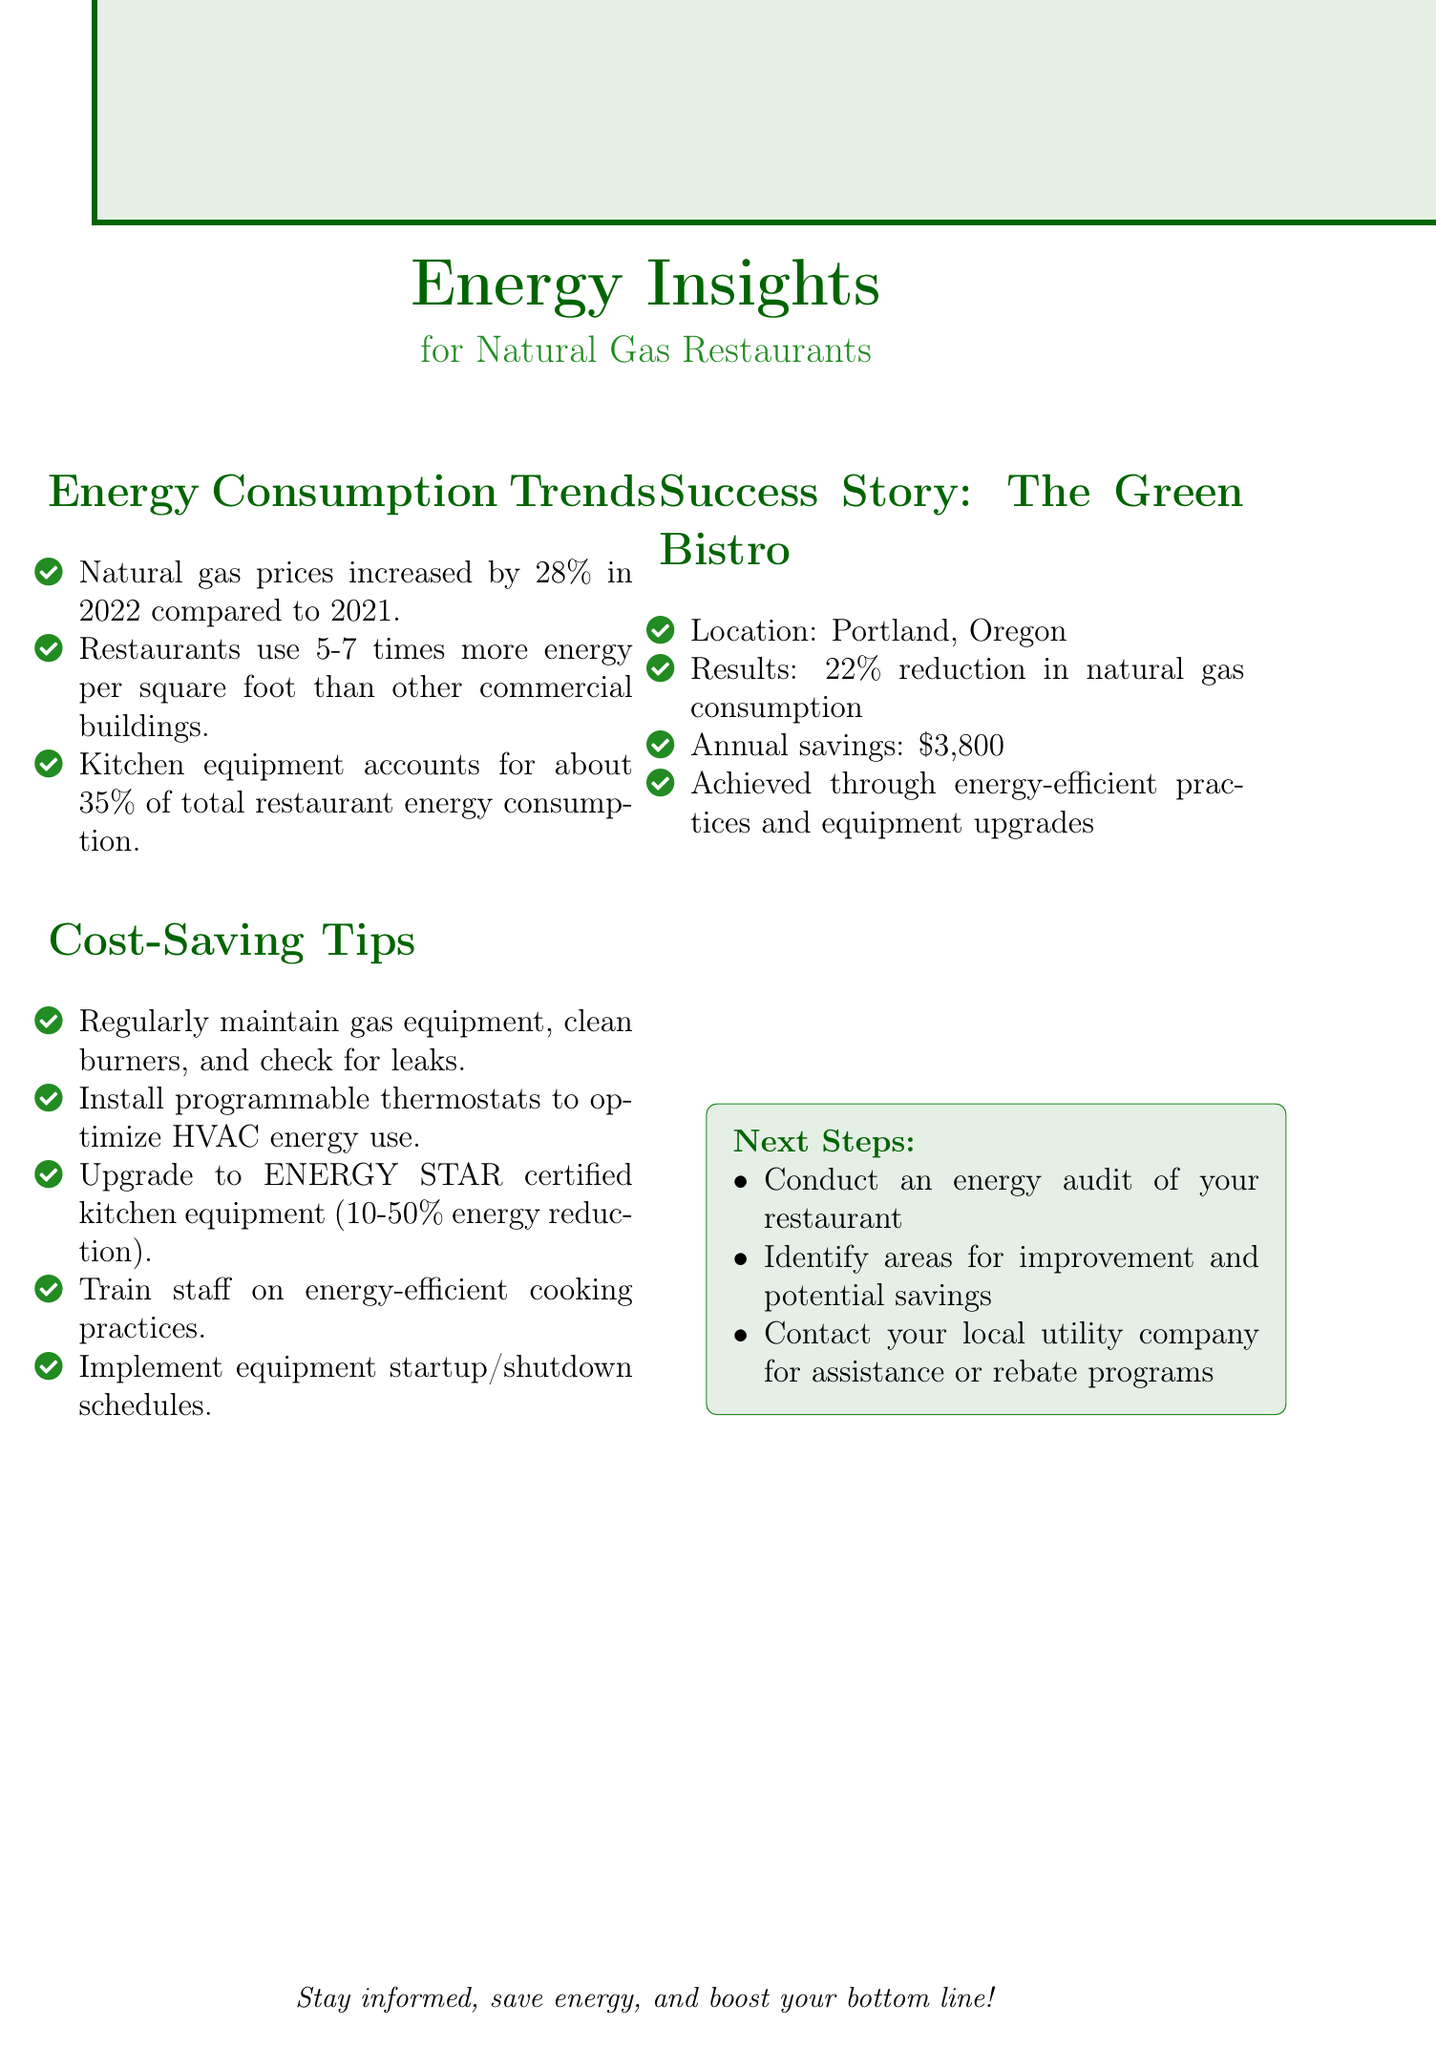what was the percentage increase in natural gas prices in 2022? The document states that natural gas prices increased by 28% in 2022 compared to 2021.
Answer: 28% how much does kitchen equipment account for total energy consumption in restaurants? The document indicates that kitchen equipment accounts for approximately 35% of total energy consumption in restaurants.
Answer: 35% what is one of the cost-saving tips mentioned in the document? The document lists several tips, one being "Regular maintenance of gas equipment, including cleaning burners and checking for gas leaks."
Answer: Regular maintenance of gas equipment how much did The Green Bistro save annually by implementing energy-efficient practices? The case study mentions that The Green Bistro saved $3,800 annually by implementing energy-efficient practices.
Answer: $3,800 what is the main purpose of conducting an energy audit? The document suggests conducting an energy audit to identify areas for improvement and potential savings.
Answer: Identify areas for improvement and potential savings which city is The Green Bistro located in? The case study specifies that The Green Bistro is located in Portland, Oregon.
Answer: Portland, Oregon how much reduction in natural gas consumption did The Green Bistro achieve? The document states that The Green Bistro reduced natural gas consumption by 22%.
Answer: 22% what should a restaurant owner consider contacting for assistance? The document advises reaching out to the local utility company for assistance or rebate programs.
Answer: Local utility company 